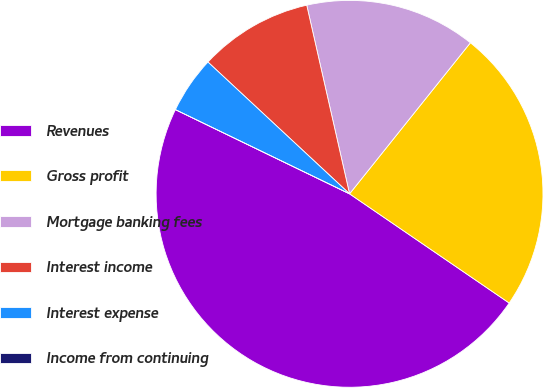<chart> <loc_0><loc_0><loc_500><loc_500><pie_chart><fcel>Revenues<fcel>Gross profit<fcel>Mortgage banking fees<fcel>Interest income<fcel>Interest expense<fcel>Income from continuing<nl><fcel>47.62%<fcel>23.81%<fcel>14.29%<fcel>9.52%<fcel>4.76%<fcel>0.0%<nl></chart> 